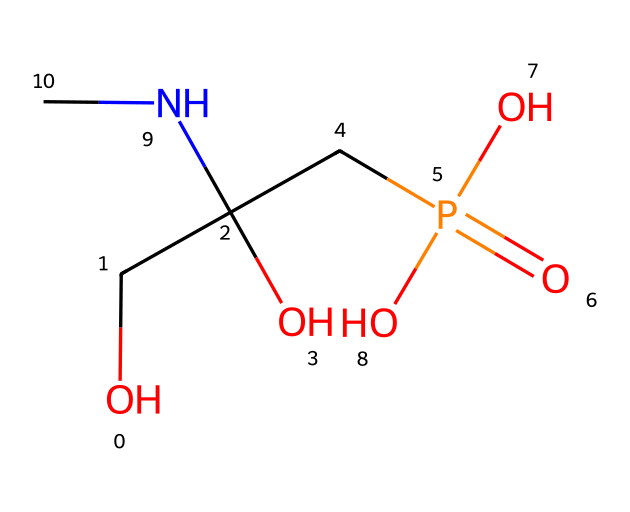What is the primary functional group in this chemical? The structure contains a phosphate group represented by the P(=O)(O)O part, indicating its role in phosphate compounds.
Answer: phosphate How many carbon atoms are present in the chemical? By examining the structure, there are three carbon atoms contributed by the "C" and "CC" segments in the SMILES notation.
Answer: three What type of bonding is evident in the nitrogen atom of this chemical? The nitrogen (N) appears to be bonded to a carbon and a hydrogen, indicating it is likely involved in an amine group, showcasing covalent bonding.
Answer: covalent Which atom in this chemical contributes to its potential toxicity? The nitrogen atom is a common contributor to toxicity in chemicals due to its presence in herbicides, impacting metabolic processes in organisms.
Answer: nitrogen How many oxygen atoms are present in the chemical composition? There are four oxygen atoms present, seen from the phosphate and hydroxyl (OH) groups in the structure of the chemical.
Answer: four Does this chemical have acidic properties? With the presence of multiple hydroxyl (OH) groups and the phosphate group, it indicates that it can release protons, contributing to acidic properties.
Answer: yes 